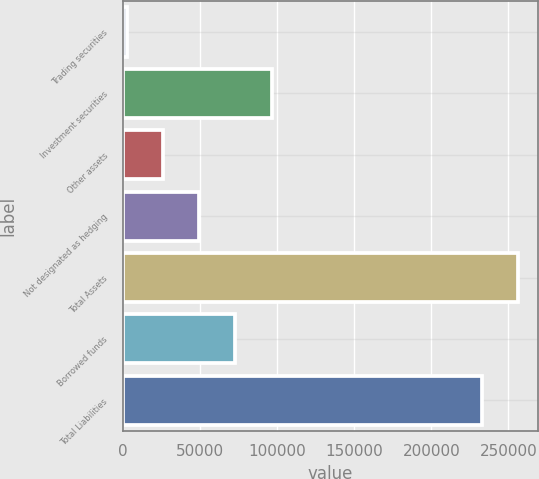Convert chart. <chart><loc_0><loc_0><loc_500><loc_500><bar_chart><fcel>Trading securities<fcel>Investment securities<fcel>Other assets<fcel>Not designated as hedging<fcel>Total Assets<fcel>Borrowed funds<fcel>Total Liabilities<nl><fcel>2513<fcel>96508.2<fcel>26011.8<fcel>49510.6<fcel>256261<fcel>73009.4<fcel>232762<nl></chart> 